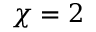Convert formula to latex. <formula><loc_0><loc_0><loc_500><loc_500>\chi = 2</formula> 